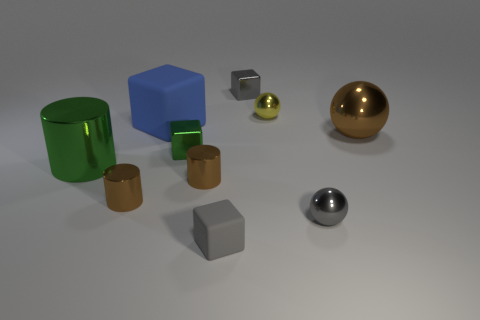Are there any purple rubber blocks that have the same size as the blue matte object?
Give a very brief answer. No. There is a block in front of the gray shiny sphere; what color is it?
Offer a very short reply. Gray. Is there a tiny green thing that is in front of the tiny gray block that is in front of the gray shiny ball?
Keep it short and to the point. No. How many other objects are there of the same color as the big shiny cylinder?
Provide a short and direct response. 1. There is a brown thing that is to the right of the yellow metallic thing; is it the same size as the gray cube that is behind the large brown metallic thing?
Your answer should be very brief. No. There is a brown cylinder right of the tiny cylinder that is to the left of the big cube; what size is it?
Offer a terse response. Small. What is the material of the large object that is to the left of the small rubber object and on the right side of the big green metallic cylinder?
Give a very brief answer. Rubber. What color is the big matte cube?
Provide a succinct answer. Blue. Are there any other things that are the same material as the large brown object?
Make the answer very short. Yes. The big thing to the right of the small yellow metal thing has what shape?
Offer a terse response. Sphere. 